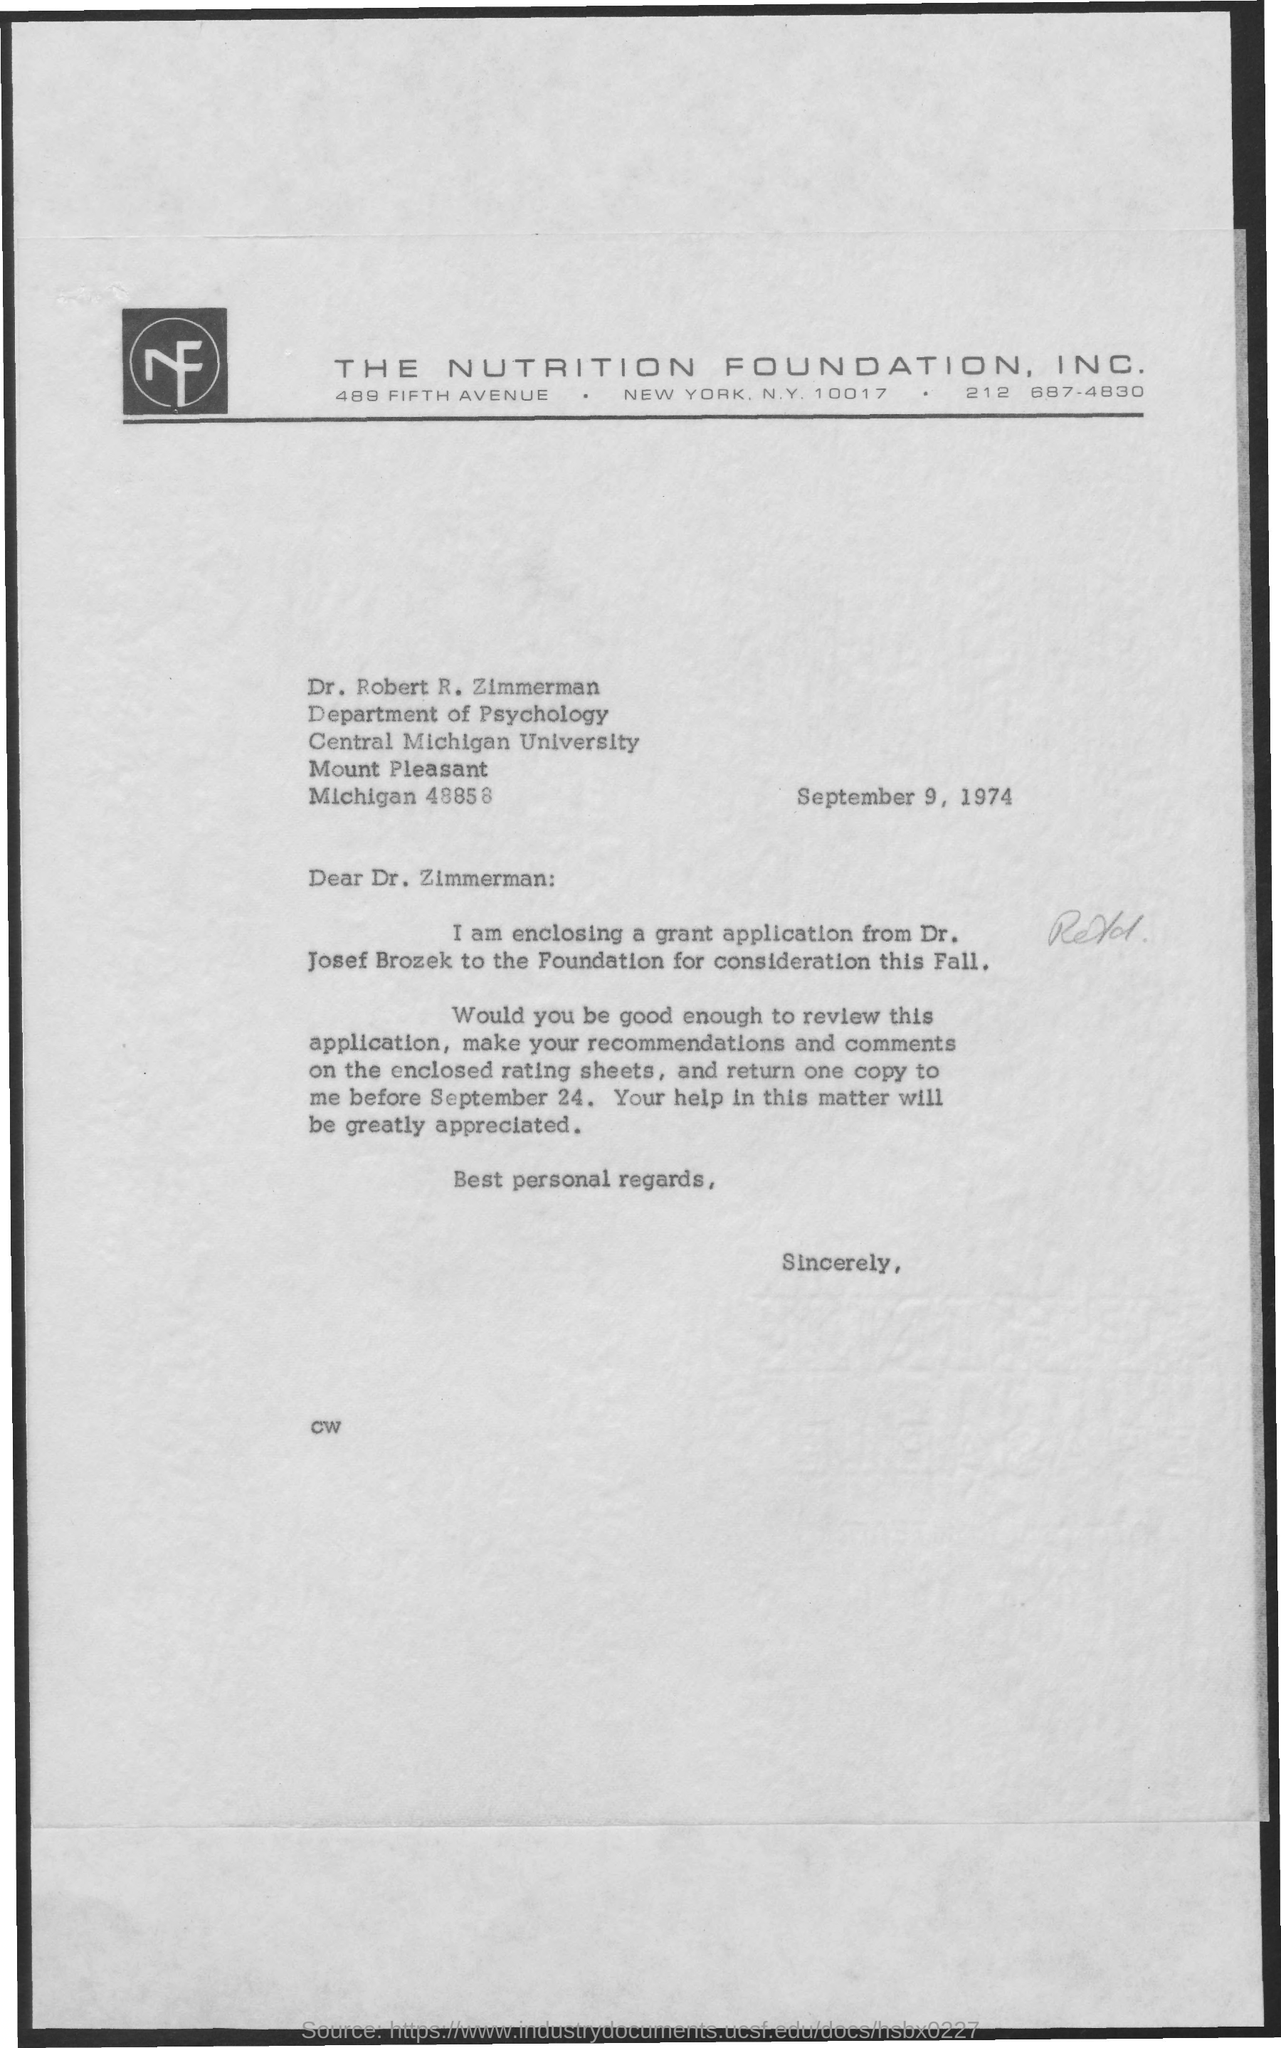Which company is mentioned in the letter head?
Provide a short and direct response. THE NUTRITION FOUNDATION, INC. What is the date mentioned in the letter?
Offer a terse response. September 9, 1974. In which deparment, Dr. Robert R. Zimmerman works?
Give a very brief answer. Department of psychology. 